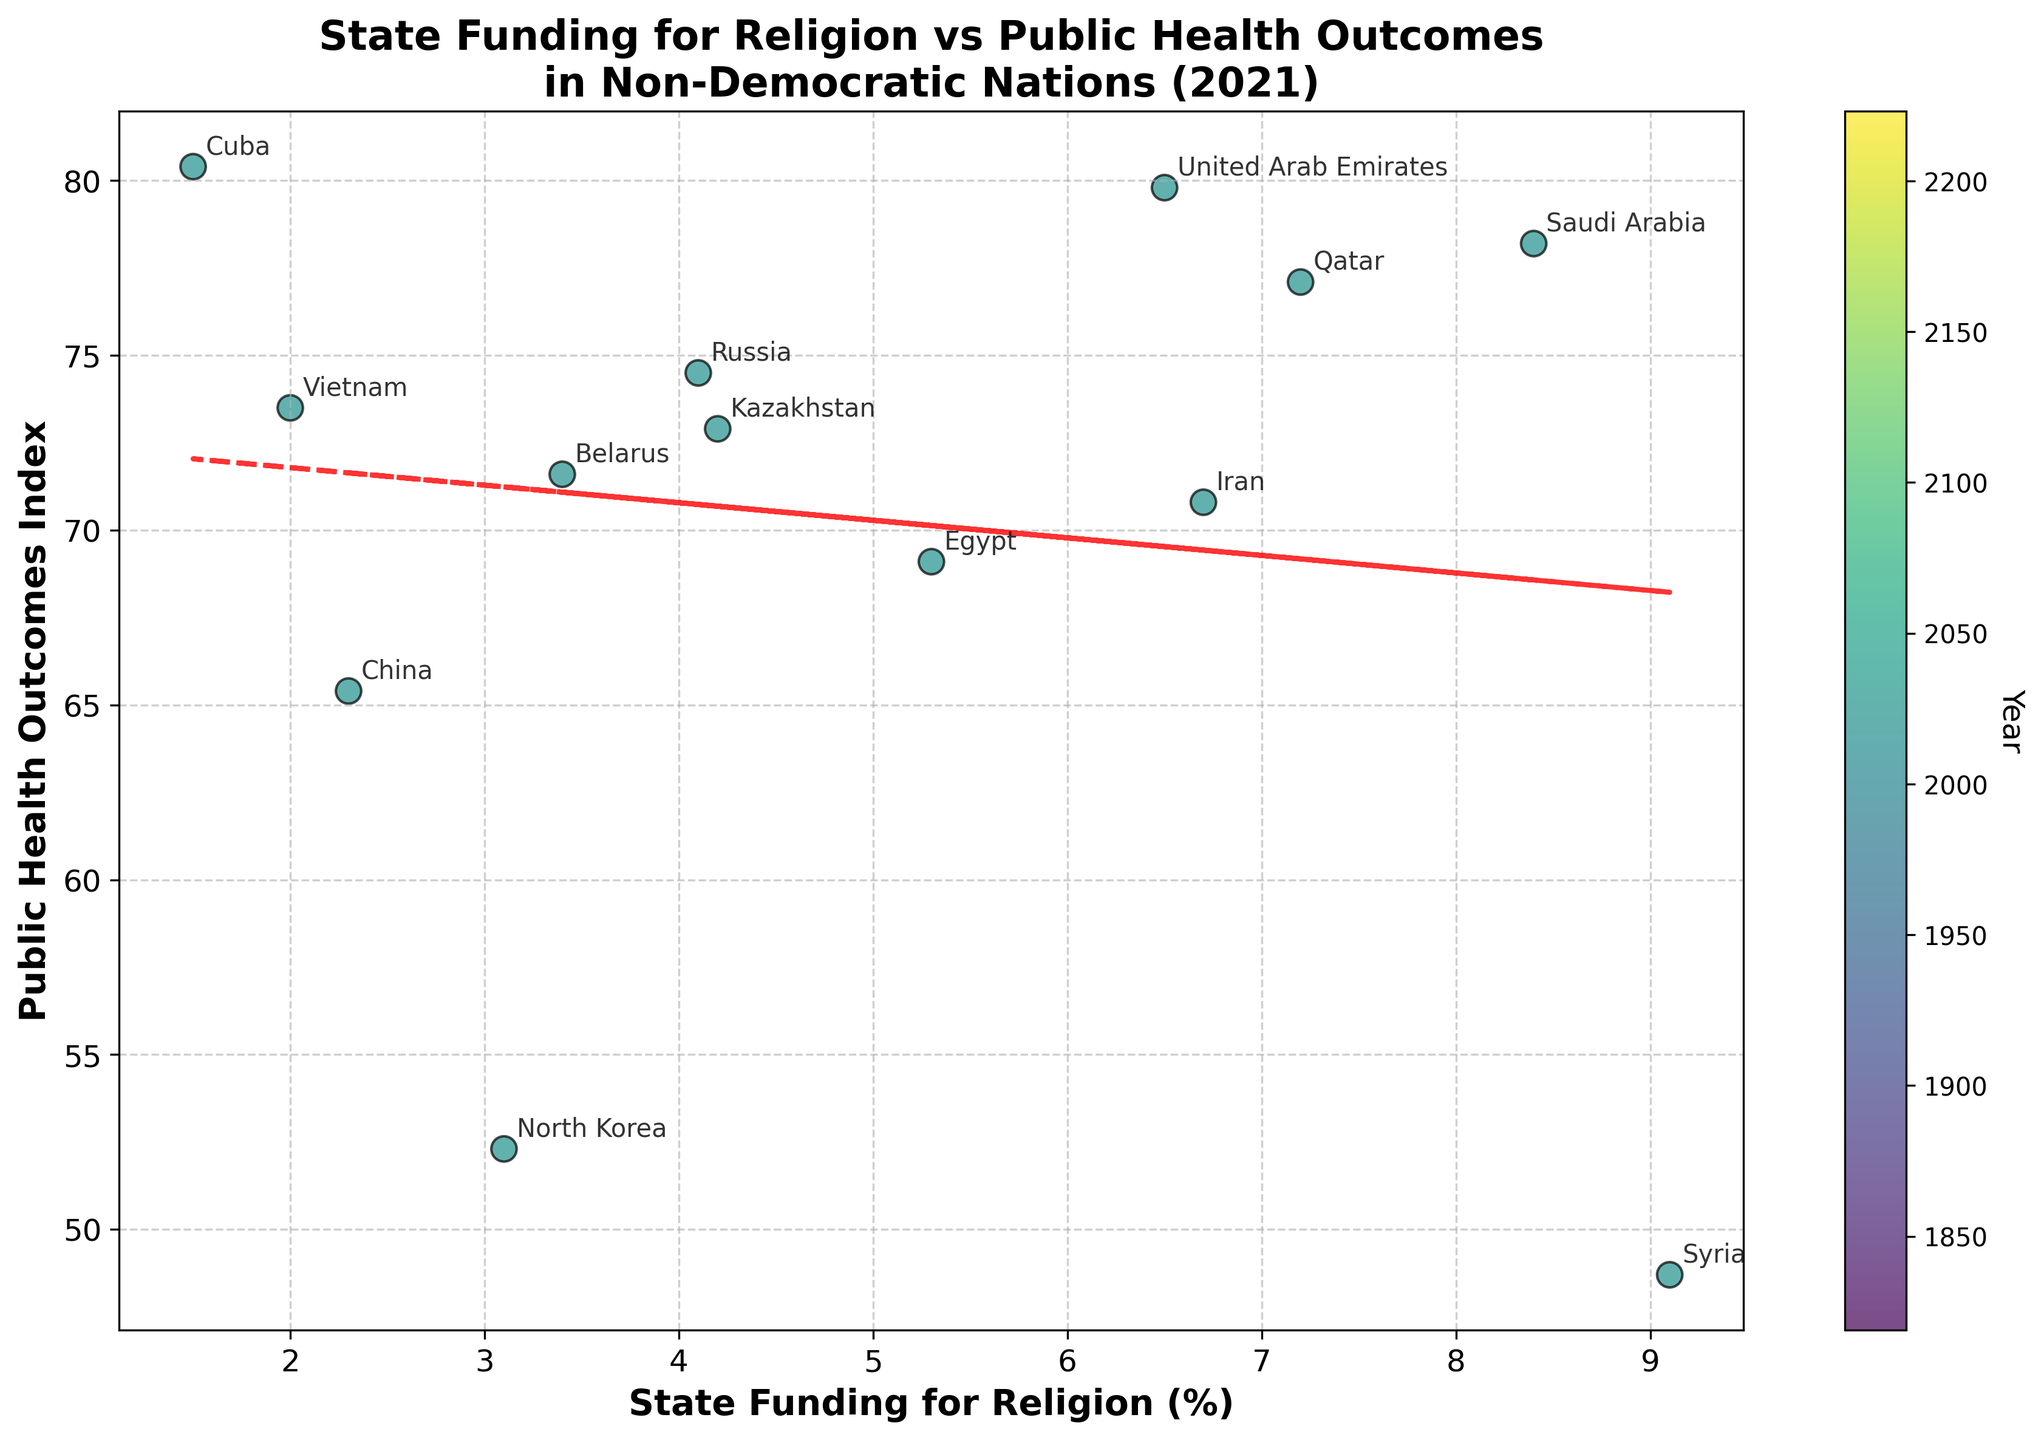Which country has the highest state funding for religion? Refer to the scatter points to identify the country with the highest x-axis value. Syria has the highest state funding for religion at 9.1%.
Answer: Syria What is the relationship between state funding for religion and public health outcomes as indicated by the trend line? Observe the slope of the trend line. The trend line shows a slightly negative slope, indicating a slight negative relationship between state funding for religion and public health outcomes.
Answer: Slight negative relationship Which country has the highest public health outcomes index? Refer to the scatter points to identify the country with the highest y-axis value. Cuba has the highest public health outcomes index at 80.4.
Answer: Cuba Compare the public health outcomes index of Qatar and Egypt. Which one is higher? Locate the points for Qatar and Egypt on the scatter plot and compare their y-axis values. Qatar's public health outcomes index (77.1) is higher than Egypt's (69.1).
Answer: Qatar What is the general trend in public health outcomes as state funding for religion increases? Analyze the trend line to see how the public health outcomes index changes with increasing state funding for religion. The trend line shows a slight decrease as state funding for religion increases, indicating a general trend towards lower public health outcomes.
Answer: Slight decrease What is the difference in public health outcomes between Saudi Arabia and Syria? Locate the scatter points for Saudi Arabia and Syria, and subtract Syria's public health outcomes index (48.7) from Saudi Arabia's (78.2). 78.2 - 48.7 = 29.5.
Answer: 29.5 Are there any countries with state funding for religion below 3%? If so, name them. Look at the scatter plot points to find countries with an x-axis value below 3%. The countries are China (2.3%), Vietnam (2.0%), and Cuba (1.5%).
Answer: China, Vietnam, Cuba Which country has the closest to median public health outcomes index among the listed countries? List all the public health outcomes index values, sort them, and find the median. The median of the given values is 71.6, which corresponds to Belarus.
Answer: Belarus What is the public health outcome index of the country with the second highest state funding for religion? Identify the country with the second highest state funding for religion percentage, which is Syria with 9.1%, and the second highest is Saudi Arabia with 8.4%. Saudi Arabia's public health outcome is 78.2.
Answer: Saudi Arabia, 78.2 Which countries are above the trend line, and what does it imply? Identify the scatter points above the trend line. These countries include Cuba, Vietnam, United Arab Emirates, Saudi Arabia, and Qatar. Being above the trend line indicates that these countries have better public health outcomes than what would be expected based on their state funding for religion.
Answer: Cuba, Vietnam, United Arab Emirates, Saudi Arabia, Qatar 